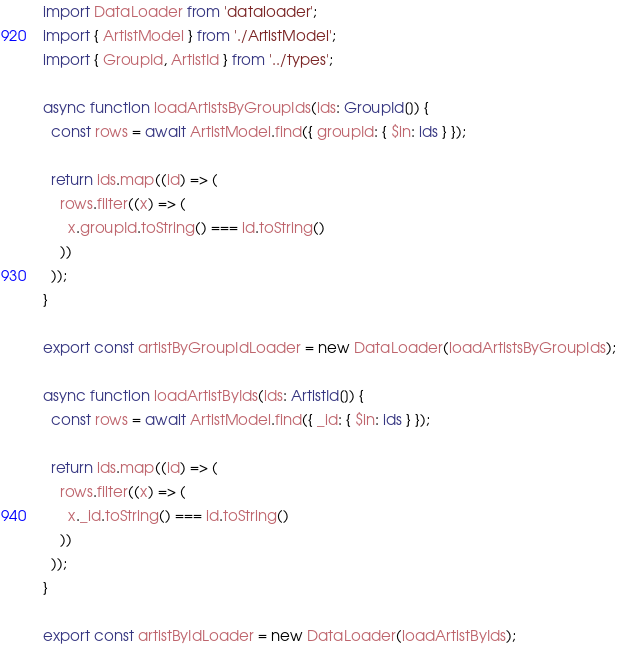<code> <loc_0><loc_0><loc_500><loc_500><_TypeScript_>import DataLoader from 'dataloader';
import { ArtistModel } from './ArtistModel';
import { GroupId, ArtistId } from '../types';

async function loadArtistsByGroupIds(ids: GroupId[]) {
  const rows = await ArtistModel.find({ groupId: { $in: ids } });

  return ids.map((id) => (
    rows.filter((x) => (
      x.groupId.toString() === id.toString()
    ))
  ));
}

export const artistByGroupIdLoader = new DataLoader(loadArtistsByGroupIds);

async function loadArtistByIds(ids: ArtistId[]) {
  const rows = await ArtistModel.find({ _id: { $in: ids } });

  return ids.map((id) => (
    rows.filter((x) => (
      x._id.toString() === id.toString()
    ))
  ));
}

export const artistByIdLoader = new DataLoader(loadArtistByIds);
</code> 